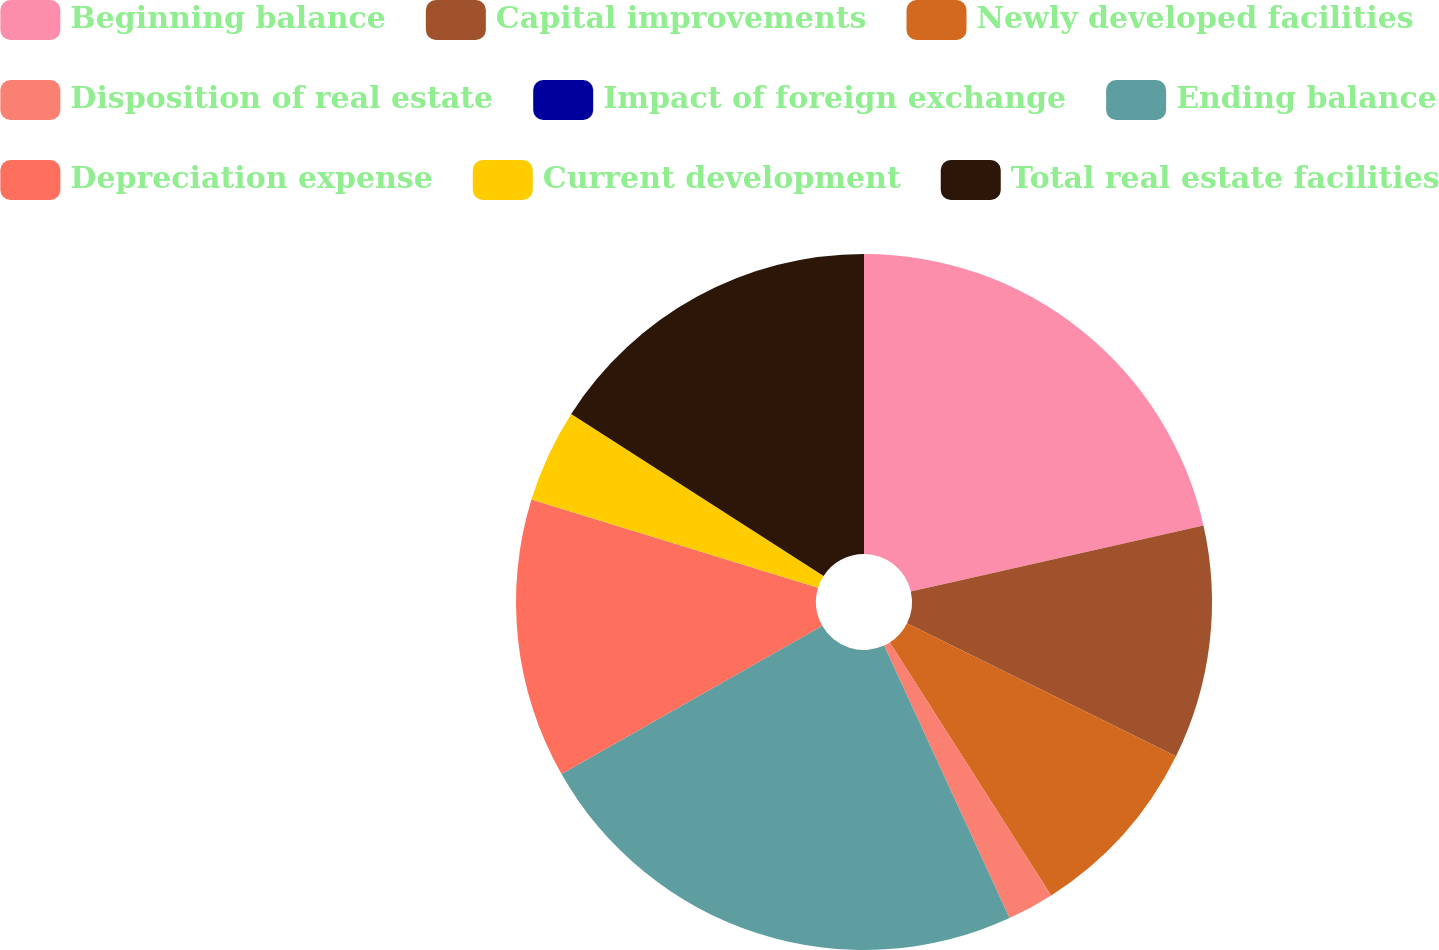Convert chart to OTSL. <chart><loc_0><loc_0><loc_500><loc_500><pie_chart><fcel>Beginning balance<fcel>Capital improvements<fcel>Newly developed facilities<fcel>Disposition of real estate<fcel>Impact of foreign exchange<fcel>Ending balance<fcel>Depreciation expense<fcel>Current development<fcel>Total real estate facilities<nl><fcel>21.47%<fcel>10.83%<fcel>8.66%<fcel>2.17%<fcel>0.0%<fcel>23.63%<fcel>12.99%<fcel>4.33%<fcel>15.91%<nl></chart> 